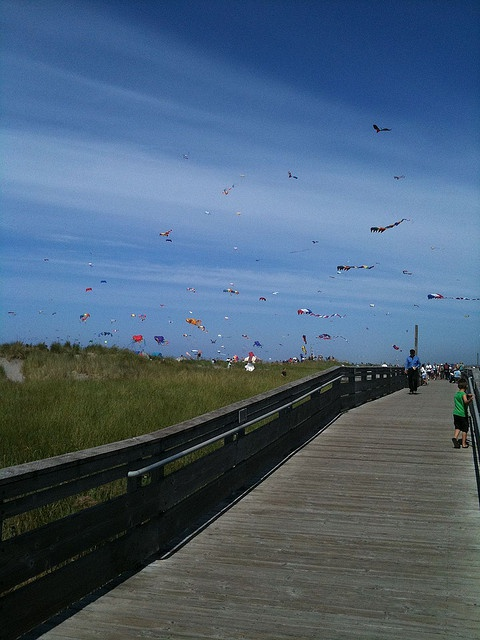Describe the objects in this image and their specific colors. I can see kite in blue, gray, and darkgreen tones, people in blue, black, gray, darkgreen, and green tones, people in blue, black, navy, and gray tones, kite in blue, gray, and darkgray tones, and kite in blue, gray, and navy tones in this image. 